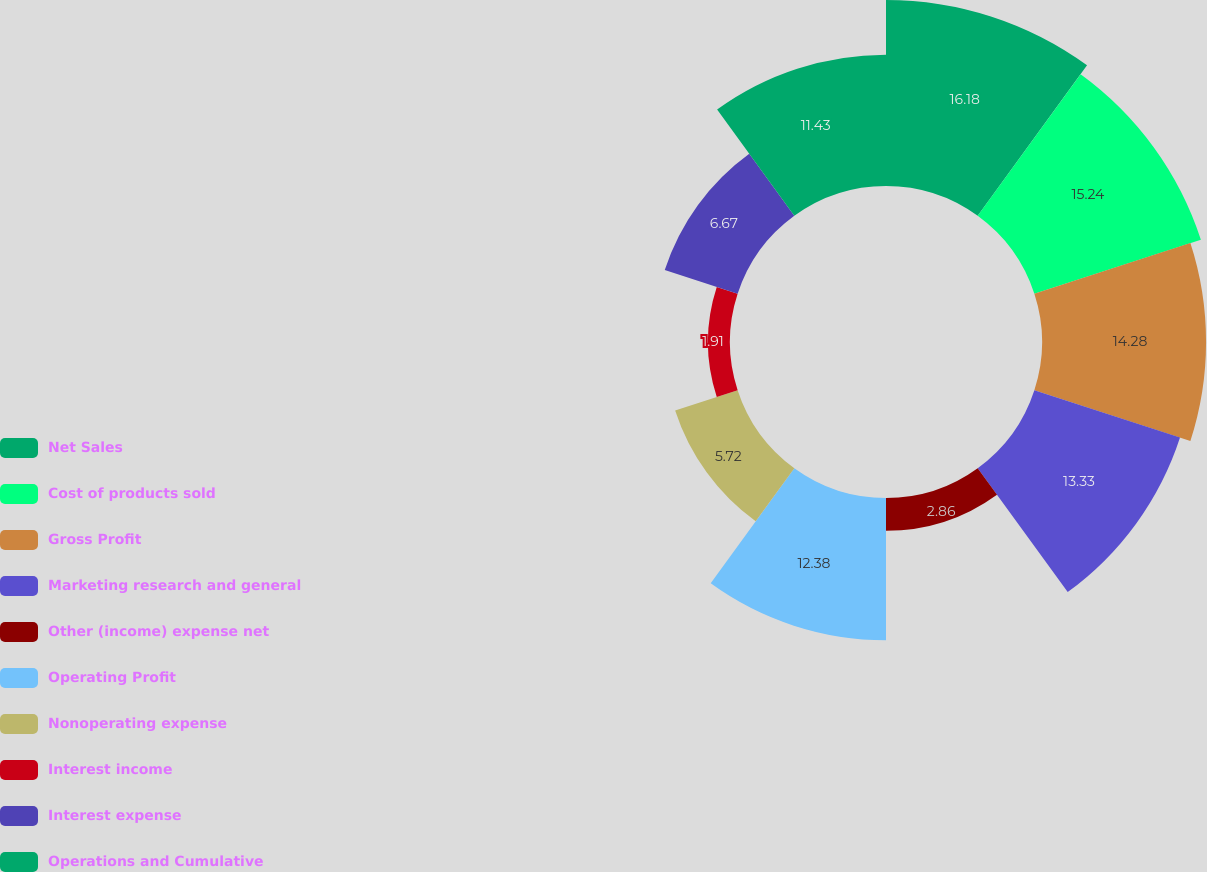Convert chart to OTSL. <chart><loc_0><loc_0><loc_500><loc_500><pie_chart><fcel>Net Sales<fcel>Cost of products sold<fcel>Gross Profit<fcel>Marketing research and general<fcel>Other (income) expense net<fcel>Operating Profit<fcel>Nonoperating expense<fcel>Interest income<fcel>Interest expense<fcel>Operations and Cumulative<nl><fcel>16.19%<fcel>15.24%<fcel>14.28%<fcel>13.33%<fcel>2.86%<fcel>12.38%<fcel>5.72%<fcel>1.91%<fcel>6.67%<fcel>11.43%<nl></chart> 